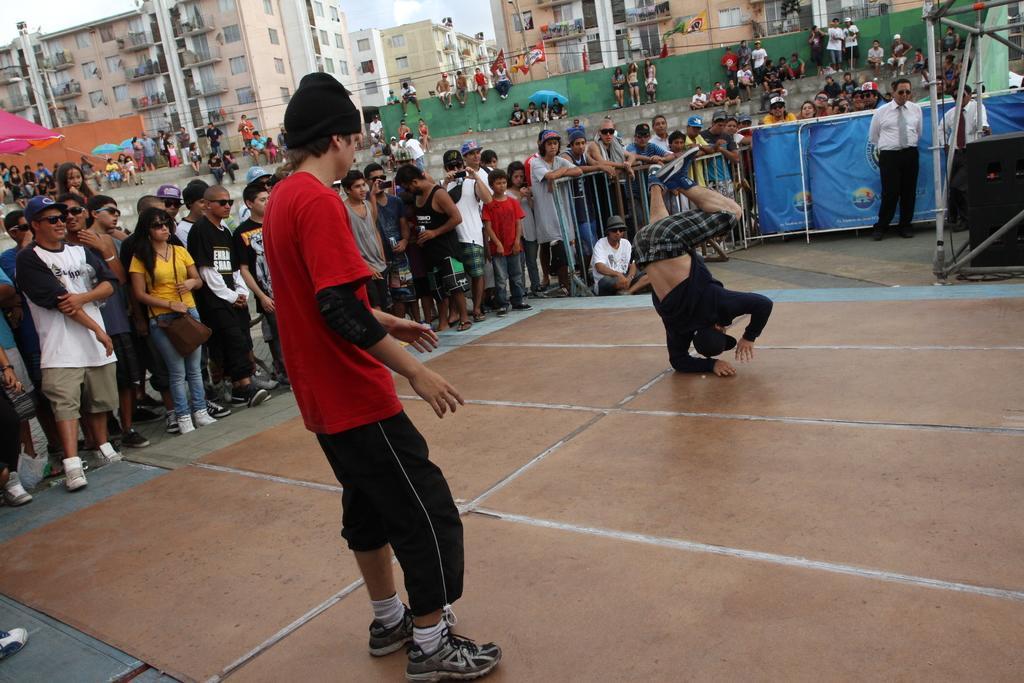In one or two sentences, can you explain what this image depicts? In this image we can see many people. Some are wearing caps. Some are wearing goggles. In the back we can see railings. Also there is a stand. In the background there are buildings with windows. Also there is sky with clouds. 